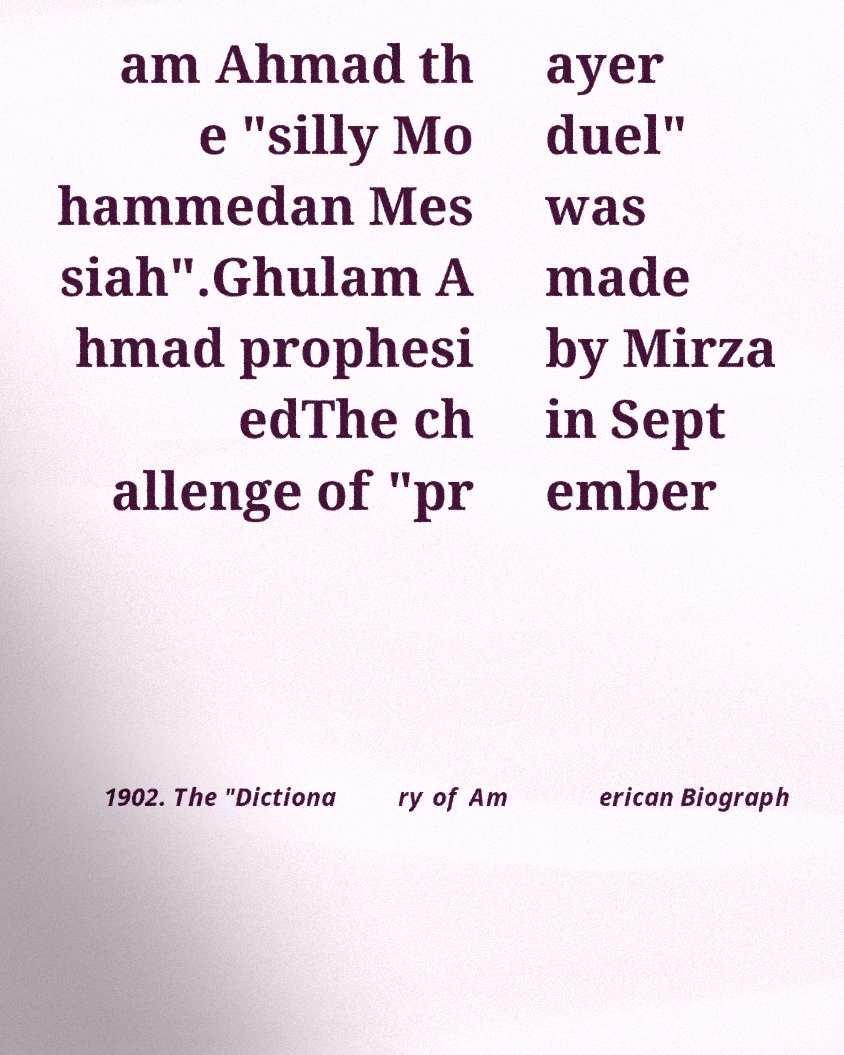I need the written content from this picture converted into text. Can you do that? am Ahmad th e "silly Mo hammedan Mes siah".Ghulam A hmad prophesi edThe ch allenge of "pr ayer duel" was made by Mirza in Sept ember 1902. The "Dictiona ry of Am erican Biograph 